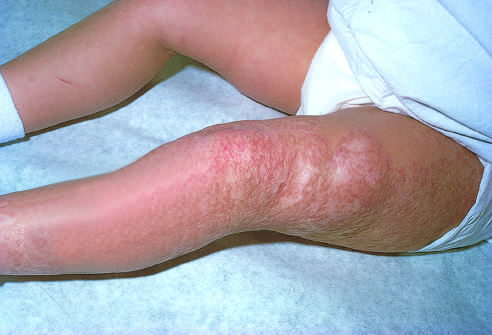had thrombus in the left and right ventricular apices undergone spontaneous regression?
Answer the question using a single word or phrase. No 